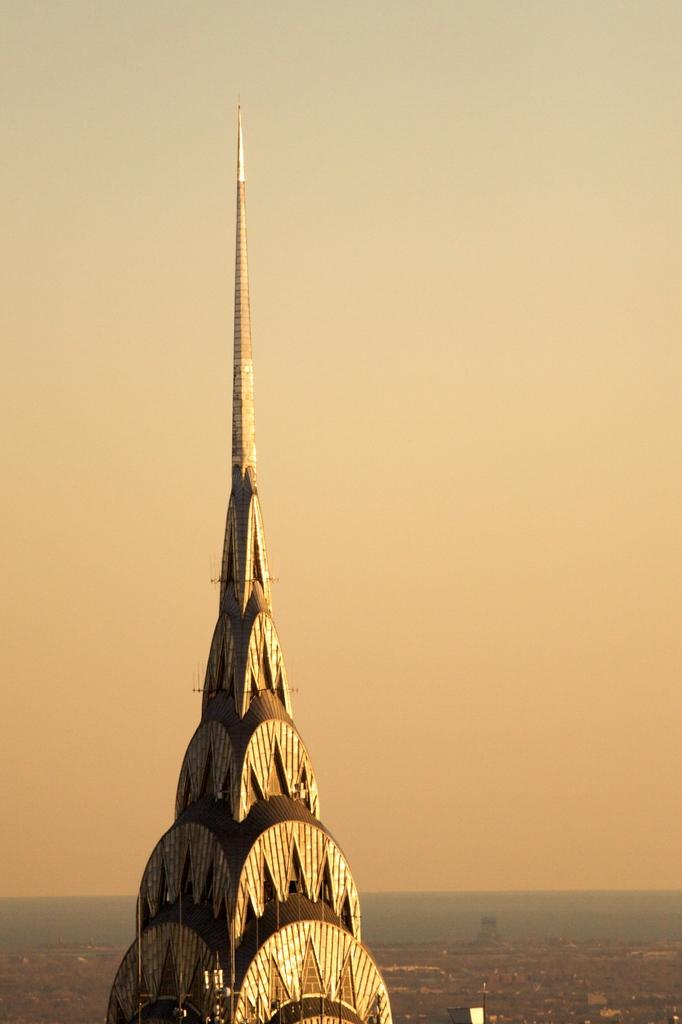What type of structure is shown in the image? The image shows the top of a building. What can be seen in the background of the image? There is sky, water, and ground visible in the background of the image. How many cushions are placed on the land in the image? There are no cushions present in the image, and the term "land" is not applicable as the image shows the top of a building. 